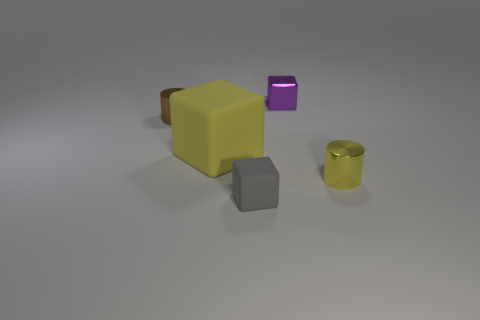Can you describe the appearance and potential function of the tiny purple block? The tiny purple block has a smooth, reflective surface with a luminescent glow that suggests it could be made of a type of illuminated glass or plastic. Its function is not immediately apparent, but based on its appearance, it could serve as an aesthetic object or perhaps a decorative light source. 